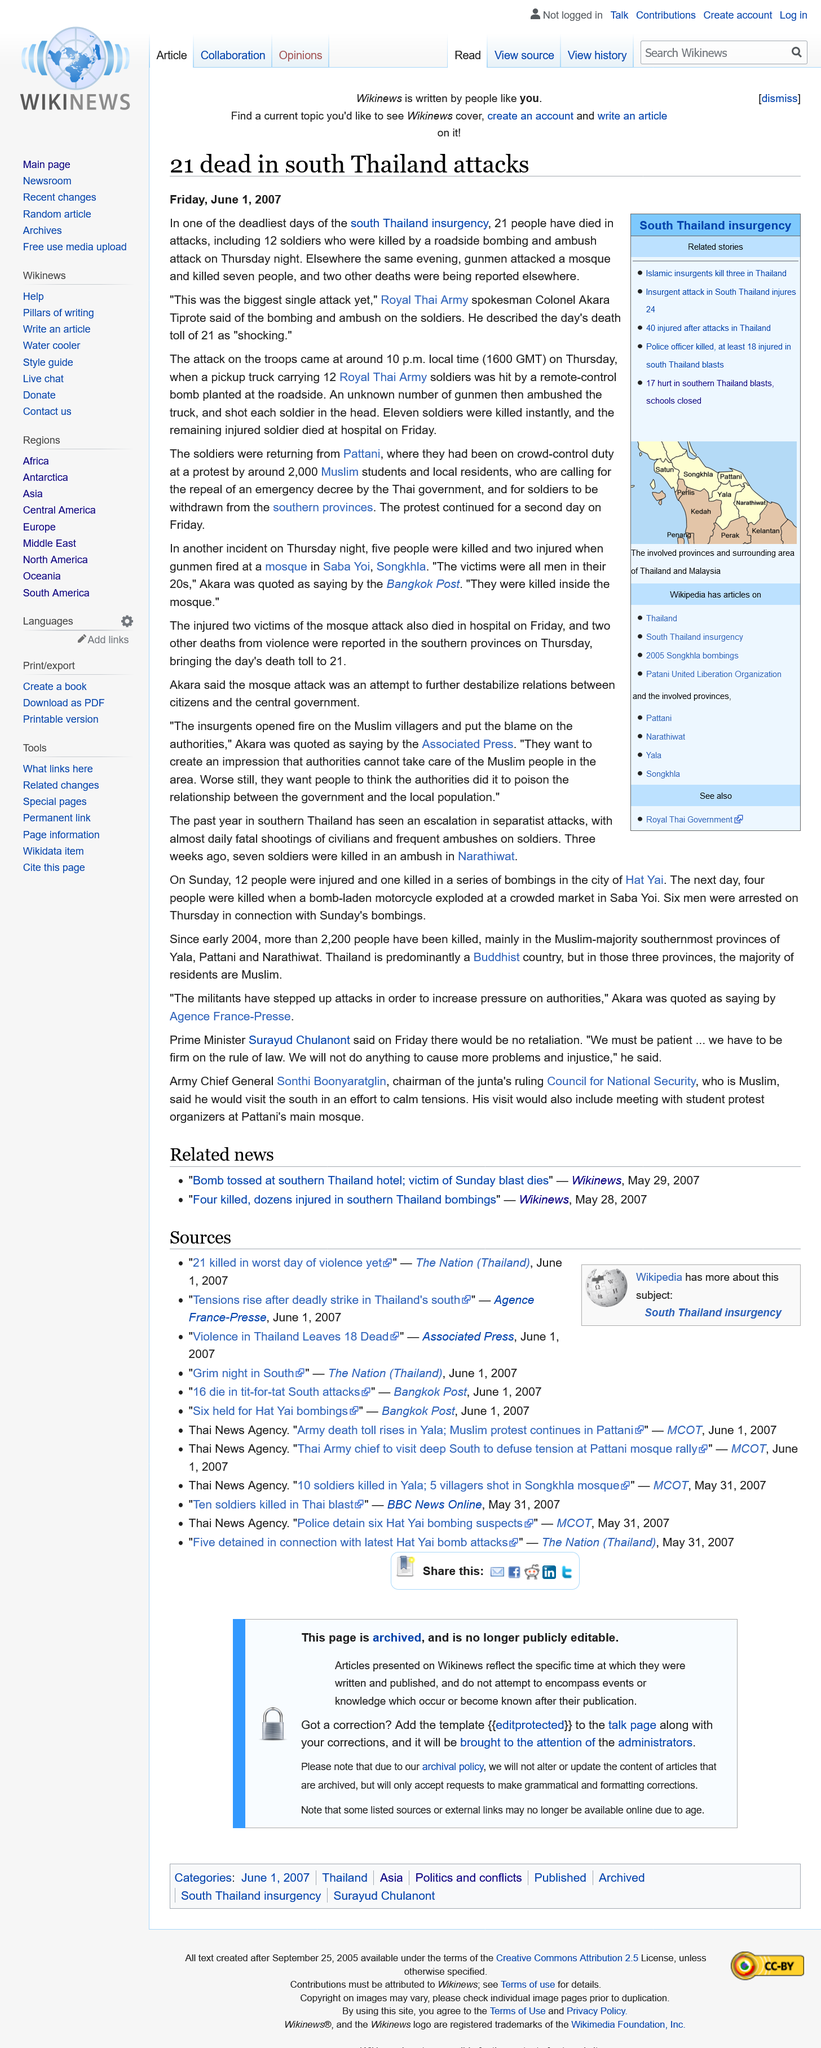List a handful of essential elements in this visual. In the same evening, gunmen attacked a mosque, resulting in the deaths of seven people, and two additional deaths were reported elsewhere. The attack on the troops occurred around 10 p.m. local time, which was approximately 1600 GMT. Twenty-one people have lost their lives in the recent attacks in the south of Thailand. 